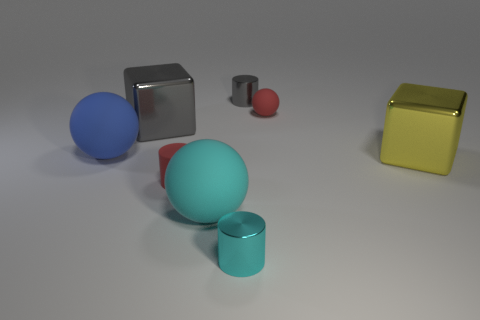What number of other objects are there of the same material as the cyan cylinder? There are three objects made of the same material as the cyan cylinder - a blue ball, a red sphere, and a small maroon cylinder. 